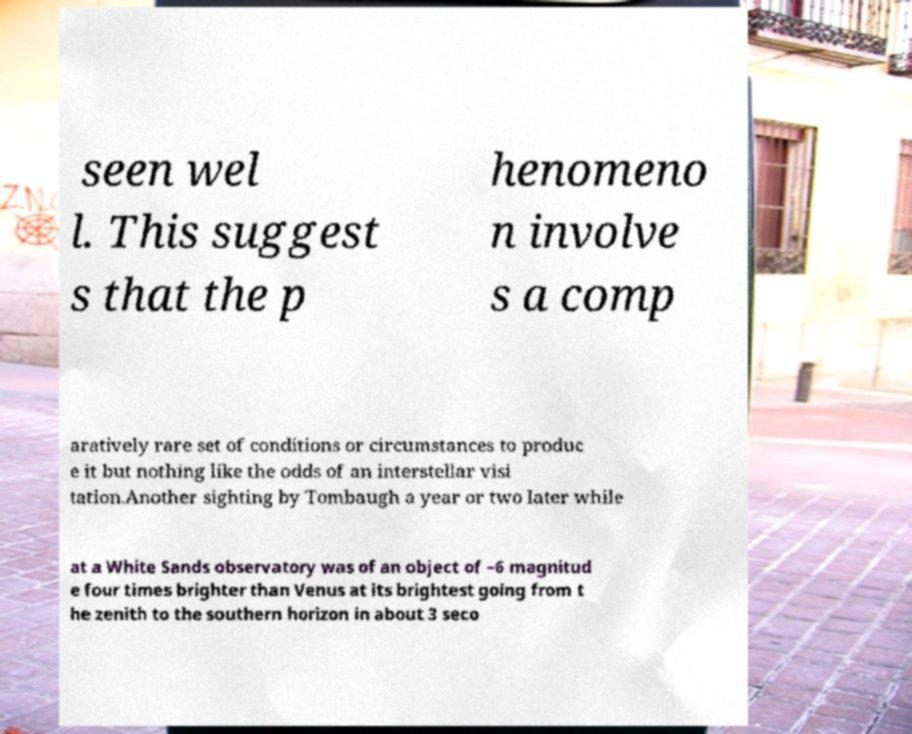Please identify and transcribe the text found in this image. seen wel l. This suggest s that the p henomeno n involve s a comp aratively rare set of conditions or circumstances to produc e it but nothing like the odds of an interstellar visi tation.Another sighting by Tombaugh a year or two later while at a White Sands observatory was of an object of −6 magnitud e four times brighter than Venus at its brightest going from t he zenith to the southern horizon in about 3 seco 